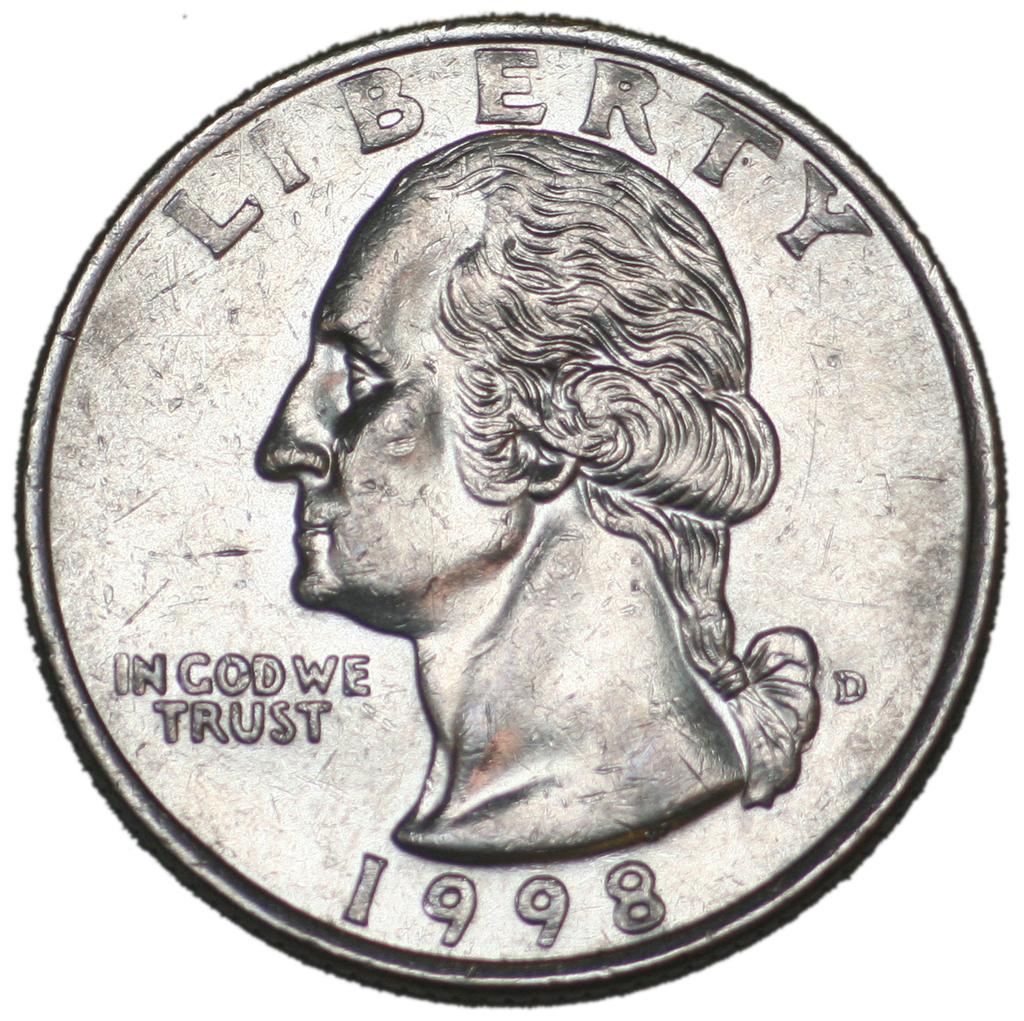<image>
Share a concise interpretation of the image provided. A silver coin that says Liberty and In God We Trust from 1998 